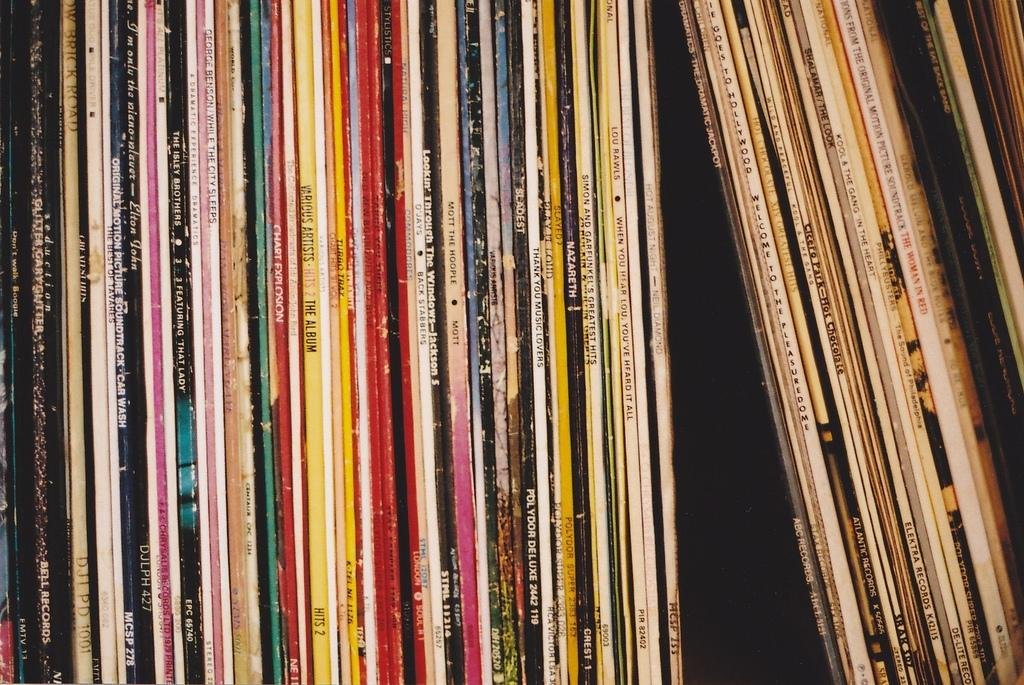<image>
Present a compact description of the photo's key features. A bunch of albums such as Thank You Music Lovers 